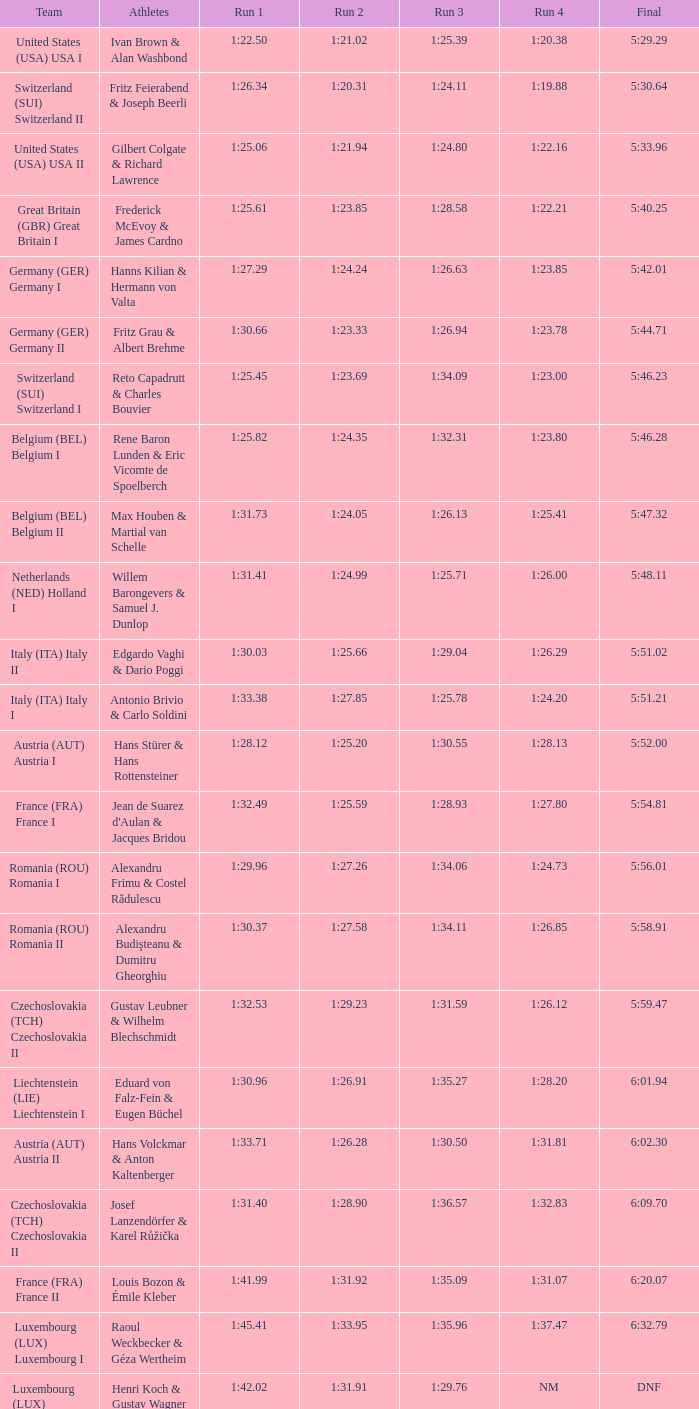Are alexandru frimu and costel rădulescu participating in run 4? 1:24.73. 